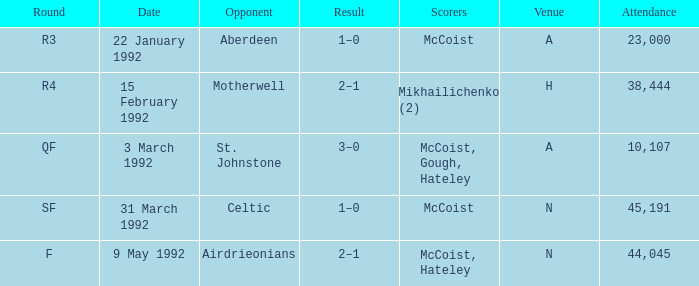In which venue was round F? N. 